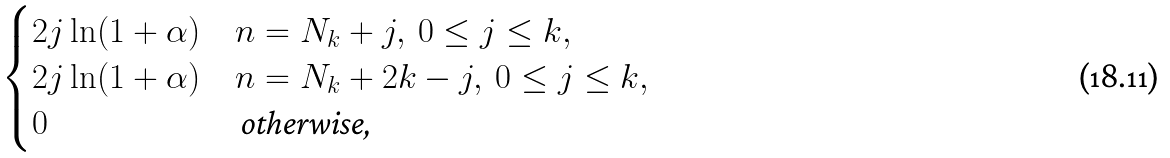<formula> <loc_0><loc_0><loc_500><loc_500>\begin{cases} 2 j \ln ( 1 + \alpha ) & n = N _ { k } + j , \ 0 \leq j \leq k , \\ 2 j \ln ( 1 + \alpha ) & n = N _ { k } + 2 k - j , \ 0 \leq j \leq k , \\ 0 & \text { otherwise, } \end{cases}</formula> 